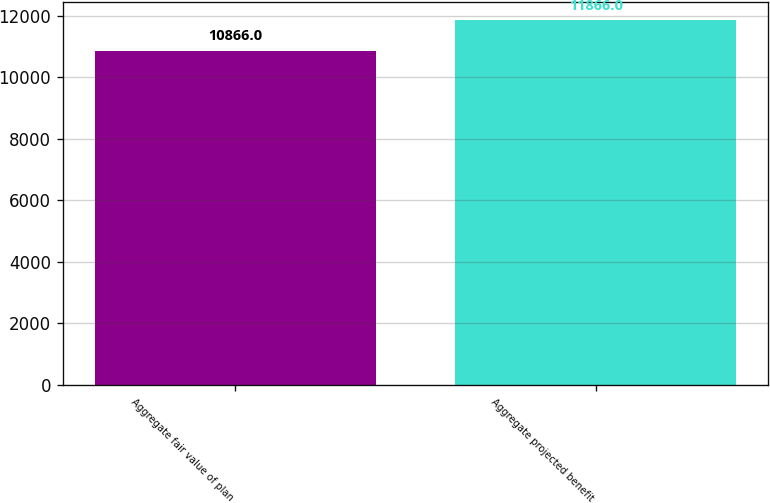<chart> <loc_0><loc_0><loc_500><loc_500><bar_chart><fcel>Aggregate fair value of plan<fcel>Aggregate projected benefit<nl><fcel>10866<fcel>11866<nl></chart> 